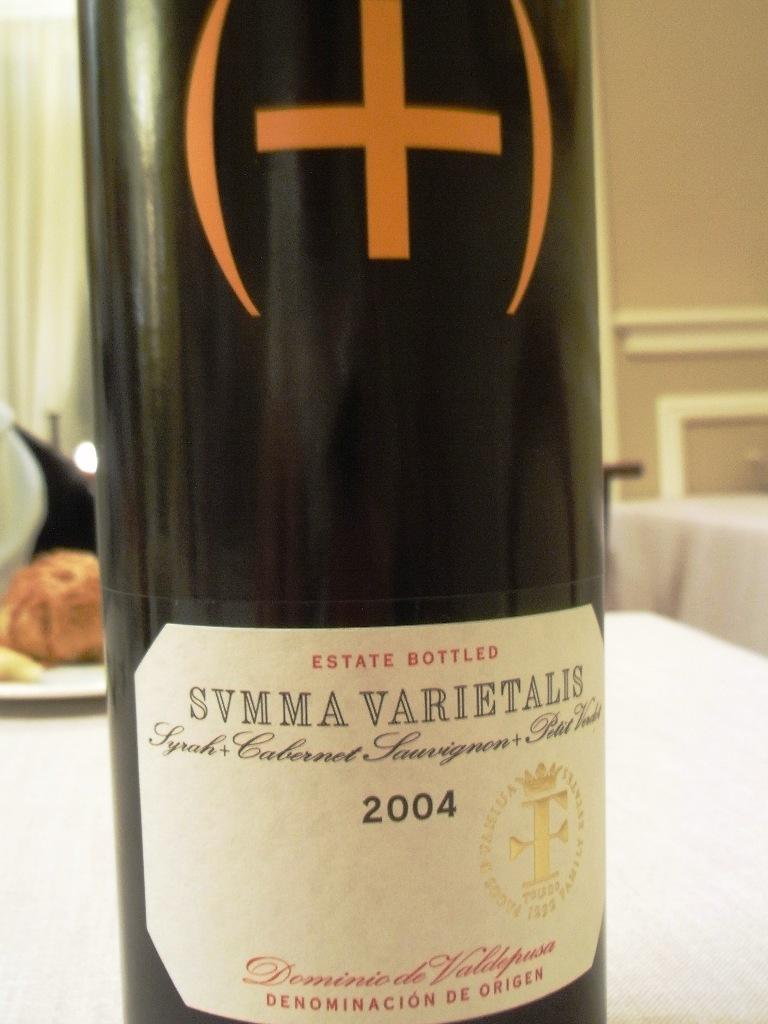<image>
Give a short and clear explanation of the subsequent image. A bottle of wine is from "2004" as stated on the label. 